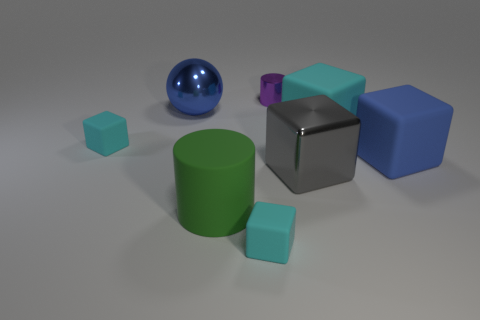There is a big green cylinder that is in front of the small metallic cylinder; what number of big gray things are to the left of it?
Give a very brief answer. 0. The metal object that is the same shape as the large blue rubber object is what color?
Keep it short and to the point. Gray. Is the material of the purple object the same as the big green object?
Give a very brief answer. No. How many cylinders are green things or large cyan rubber things?
Your answer should be very brief. 1. There is a matte cube that is on the left side of the cyan block in front of the big gray metallic cube that is on the right side of the small purple metal object; what is its size?
Your answer should be very brief. Small. What size is the other object that is the same shape as the purple object?
Offer a terse response. Large. There is a shiny cylinder; what number of small cyan objects are on the right side of it?
Give a very brief answer. 0. Is the color of the big block that is right of the big cyan matte block the same as the sphere?
Your answer should be very brief. Yes. How many gray things are large objects or spheres?
Your answer should be compact. 1. The cylinder that is in front of the cyan thing on the right side of the small purple cylinder is what color?
Your answer should be compact. Green. 